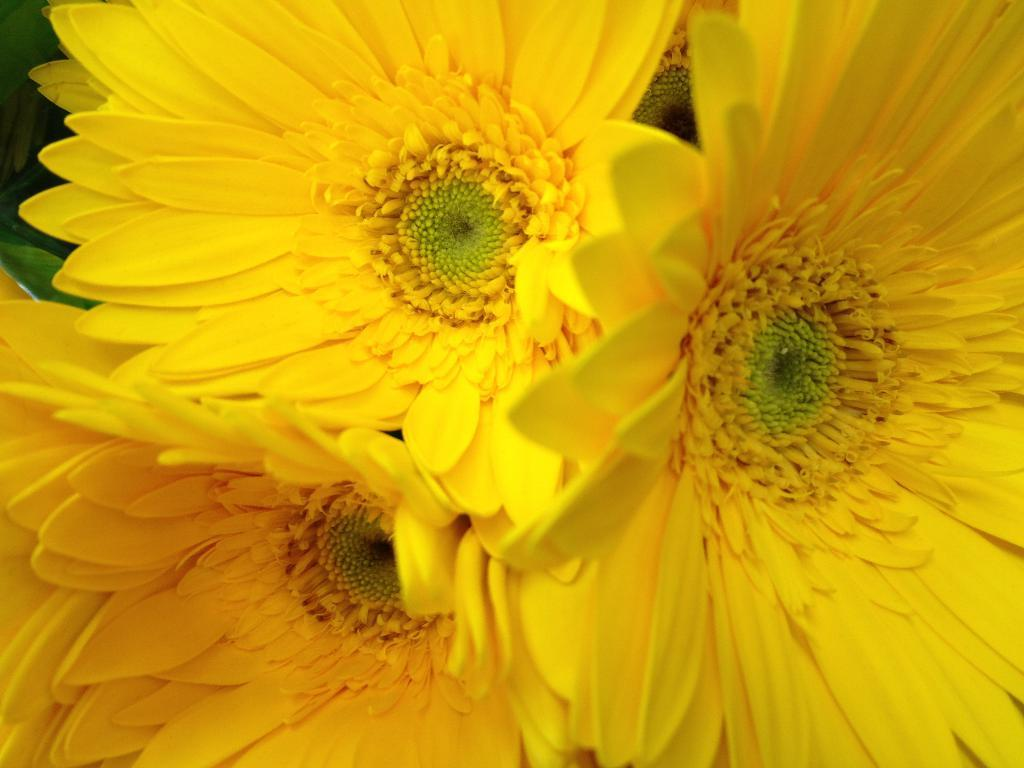What type of flowers can be seen in the image? There are yellow color flowers in the image. What type of music is being played in the background of the image? There is no music or background noise mentioned in the image, as it only features yellow color flowers. 